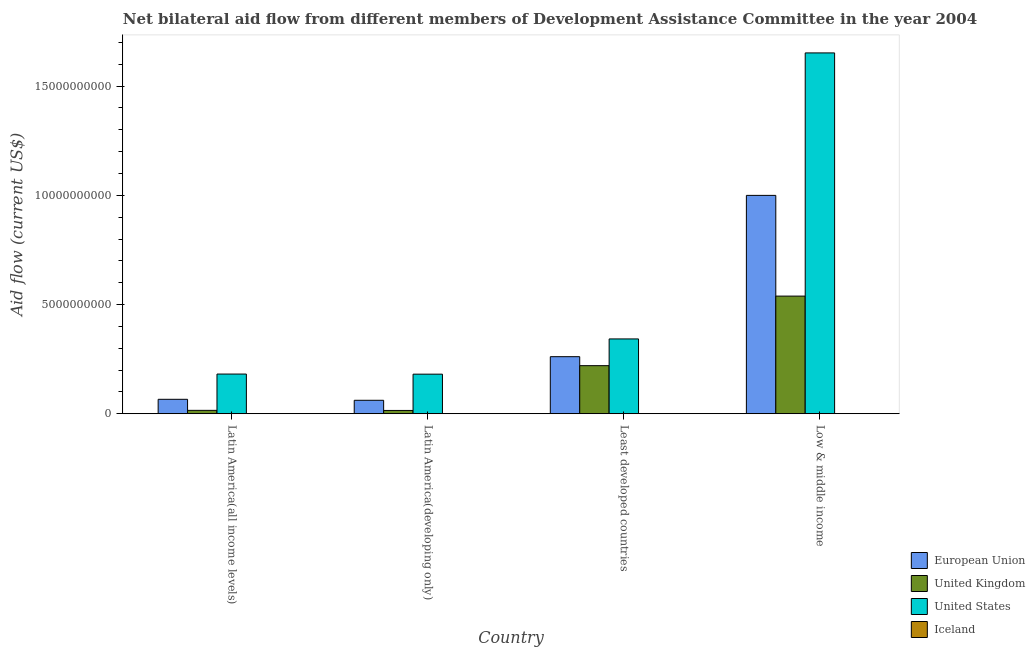How many different coloured bars are there?
Provide a succinct answer. 4. How many groups of bars are there?
Offer a very short reply. 4. Are the number of bars per tick equal to the number of legend labels?
Provide a succinct answer. Yes. How many bars are there on the 1st tick from the right?
Offer a terse response. 4. What is the label of the 1st group of bars from the left?
Your answer should be very brief. Latin America(all income levels). In how many cases, is the number of bars for a given country not equal to the number of legend labels?
Your response must be concise. 0. What is the amount of aid given by uk in Least developed countries?
Keep it short and to the point. 2.20e+09. Across all countries, what is the maximum amount of aid given by eu?
Your answer should be compact. 1.00e+1. Across all countries, what is the minimum amount of aid given by us?
Provide a succinct answer. 1.81e+09. In which country was the amount of aid given by uk minimum?
Your response must be concise. Latin America(developing only). What is the total amount of aid given by uk in the graph?
Your answer should be very brief. 7.89e+09. What is the difference between the amount of aid given by eu in Latin America(all income levels) and that in Latin America(developing only)?
Your response must be concise. 4.48e+07. What is the difference between the amount of aid given by eu in Latin America(developing only) and the amount of aid given by iceland in Low & middle income?
Provide a succinct answer. 6.16e+08. What is the average amount of aid given by eu per country?
Your response must be concise. 3.47e+09. What is the difference between the amount of aid given by uk and amount of aid given by us in Low & middle income?
Provide a short and direct response. -1.11e+1. In how many countries, is the amount of aid given by iceland greater than 13000000000 US$?
Ensure brevity in your answer.  0. What is the ratio of the amount of aid given by eu in Least developed countries to that in Low & middle income?
Provide a short and direct response. 0.26. Is the amount of aid given by uk in Latin America(all income levels) less than that in Latin America(developing only)?
Offer a very short reply. No. Is the difference between the amount of aid given by uk in Latin America(all income levels) and Low & middle income greater than the difference between the amount of aid given by eu in Latin America(all income levels) and Low & middle income?
Offer a terse response. Yes. What is the difference between the highest and the second highest amount of aid given by uk?
Provide a short and direct response. 3.18e+09. What is the difference between the highest and the lowest amount of aid given by iceland?
Offer a terse response. 7.55e+06. Is it the case that in every country, the sum of the amount of aid given by us and amount of aid given by eu is greater than the sum of amount of aid given by iceland and amount of aid given by uk?
Provide a short and direct response. No. Are all the bars in the graph horizontal?
Give a very brief answer. No. Does the graph contain any zero values?
Offer a very short reply. No. Does the graph contain grids?
Provide a short and direct response. No. Where does the legend appear in the graph?
Provide a short and direct response. Bottom right. How many legend labels are there?
Keep it short and to the point. 4. How are the legend labels stacked?
Make the answer very short. Vertical. What is the title of the graph?
Provide a short and direct response. Net bilateral aid flow from different members of Development Assistance Committee in the year 2004. Does "Other Minerals" appear as one of the legend labels in the graph?
Keep it short and to the point. No. What is the Aid flow (current US$) in European Union in Latin America(all income levels)?
Give a very brief answer. 6.61e+08. What is the Aid flow (current US$) of United Kingdom in Latin America(all income levels)?
Provide a short and direct response. 1.55e+08. What is the Aid flow (current US$) of United States in Latin America(all income levels)?
Your answer should be compact. 1.82e+09. What is the Aid flow (current US$) of Iceland in Latin America(all income levels)?
Ensure brevity in your answer.  6.01e+06. What is the Aid flow (current US$) of European Union in Latin America(developing only)?
Make the answer very short. 6.16e+08. What is the Aid flow (current US$) in United Kingdom in Latin America(developing only)?
Your response must be concise. 1.51e+08. What is the Aid flow (current US$) of United States in Latin America(developing only)?
Your answer should be very brief. 1.81e+09. What is the Aid flow (current US$) of Iceland in Latin America(developing only)?
Your response must be concise. 2.86e+06. What is the Aid flow (current US$) of European Union in Least developed countries?
Make the answer very short. 2.61e+09. What is the Aid flow (current US$) in United Kingdom in Least developed countries?
Provide a short and direct response. 2.20e+09. What is the Aid flow (current US$) of United States in Least developed countries?
Offer a very short reply. 3.43e+09. What is the Aid flow (current US$) in Iceland in Least developed countries?
Provide a succinct answer. 7.60e+06. What is the Aid flow (current US$) of European Union in Low & middle income?
Your answer should be very brief. 1.00e+1. What is the Aid flow (current US$) of United Kingdom in Low & middle income?
Keep it short and to the point. 5.39e+09. What is the Aid flow (current US$) of United States in Low & middle income?
Offer a very short reply. 1.65e+1. What is the Aid flow (current US$) in Iceland in Low & middle income?
Your response must be concise. 5.00e+04. Across all countries, what is the maximum Aid flow (current US$) of European Union?
Your answer should be very brief. 1.00e+1. Across all countries, what is the maximum Aid flow (current US$) in United Kingdom?
Ensure brevity in your answer.  5.39e+09. Across all countries, what is the maximum Aid flow (current US$) in United States?
Keep it short and to the point. 1.65e+1. Across all countries, what is the maximum Aid flow (current US$) of Iceland?
Your response must be concise. 7.60e+06. Across all countries, what is the minimum Aid flow (current US$) of European Union?
Keep it short and to the point. 6.16e+08. Across all countries, what is the minimum Aid flow (current US$) in United Kingdom?
Offer a very short reply. 1.51e+08. Across all countries, what is the minimum Aid flow (current US$) in United States?
Ensure brevity in your answer.  1.81e+09. Across all countries, what is the minimum Aid flow (current US$) in Iceland?
Ensure brevity in your answer.  5.00e+04. What is the total Aid flow (current US$) in European Union in the graph?
Offer a very short reply. 1.39e+1. What is the total Aid flow (current US$) in United Kingdom in the graph?
Offer a terse response. 7.89e+09. What is the total Aid flow (current US$) in United States in the graph?
Keep it short and to the point. 2.36e+1. What is the total Aid flow (current US$) in Iceland in the graph?
Offer a terse response. 1.65e+07. What is the difference between the Aid flow (current US$) of European Union in Latin America(all income levels) and that in Latin America(developing only)?
Your answer should be compact. 4.48e+07. What is the difference between the Aid flow (current US$) of United Kingdom in Latin America(all income levels) and that in Latin America(developing only)?
Offer a terse response. 4.27e+06. What is the difference between the Aid flow (current US$) in United States in Latin America(all income levels) and that in Latin America(developing only)?
Your answer should be very brief. 4.96e+06. What is the difference between the Aid flow (current US$) in Iceland in Latin America(all income levels) and that in Latin America(developing only)?
Offer a very short reply. 3.15e+06. What is the difference between the Aid flow (current US$) in European Union in Latin America(all income levels) and that in Least developed countries?
Make the answer very short. -1.95e+09. What is the difference between the Aid flow (current US$) in United Kingdom in Latin America(all income levels) and that in Least developed countries?
Your response must be concise. -2.05e+09. What is the difference between the Aid flow (current US$) in United States in Latin America(all income levels) and that in Least developed countries?
Make the answer very short. -1.61e+09. What is the difference between the Aid flow (current US$) of Iceland in Latin America(all income levels) and that in Least developed countries?
Ensure brevity in your answer.  -1.59e+06. What is the difference between the Aid flow (current US$) in European Union in Latin America(all income levels) and that in Low & middle income?
Offer a terse response. -9.34e+09. What is the difference between the Aid flow (current US$) of United Kingdom in Latin America(all income levels) and that in Low & middle income?
Your answer should be very brief. -5.23e+09. What is the difference between the Aid flow (current US$) in United States in Latin America(all income levels) and that in Low & middle income?
Your response must be concise. -1.47e+1. What is the difference between the Aid flow (current US$) of Iceland in Latin America(all income levels) and that in Low & middle income?
Make the answer very short. 5.96e+06. What is the difference between the Aid flow (current US$) of European Union in Latin America(developing only) and that in Least developed countries?
Provide a short and direct response. -2.00e+09. What is the difference between the Aid flow (current US$) of United Kingdom in Latin America(developing only) and that in Least developed countries?
Keep it short and to the point. -2.05e+09. What is the difference between the Aid flow (current US$) in United States in Latin America(developing only) and that in Least developed countries?
Give a very brief answer. -1.61e+09. What is the difference between the Aid flow (current US$) in Iceland in Latin America(developing only) and that in Least developed countries?
Your answer should be very brief. -4.74e+06. What is the difference between the Aid flow (current US$) in European Union in Latin America(developing only) and that in Low & middle income?
Offer a very short reply. -9.38e+09. What is the difference between the Aid flow (current US$) in United Kingdom in Latin America(developing only) and that in Low & middle income?
Provide a short and direct response. -5.24e+09. What is the difference between the Aid flow (current US$) of United States in Latin America(developing only) and that in Low & middle income?
Offer a terse response. -1.47e+1. What is the difference between the Aid flow (current US$) in Iceland in Latin America(developing only) and that in Low & middle income?
Your answer should be very brief. 2.81e+06. What is the difference between the Aid flow (current US$) in European Union in Least developed countries and that in Low & middle income?
Provide a short and direct response. -7.39e+09. What is the difference between the Aid flow (current US$) in United Kingdom in Least developed countries and that in Low & middle income?
Your answer should be very brief. -3.18e+09. What is the difference between the Aid flow (current US$) in United States in Least developed countries and that in Low & middle income?
Give a very brief answer. -1.31e+1. What is the difference between the Aid flow (current US$) in Iceland in Least developed countries and that in Low & middle income?
Keep it short and to the point. 7.55e+06. What is the difference between the Aid flow (current US$) in European Union in Latin America(all income levels) and the Aid flow (current US$) in United Kingdom in Latin America(developing only)?
Make the answer very short. 5.10e+08. What is the difference between the Aid flow (current US$) of European Union in Latin America(all income levels) and the Aid flow (current US$) of United States in Latin America(developing only)?
Offer a terse response. -1.15e+09. What is the difference between the Aid flow (current US$) of European Union in Latin America(all income levels) and the Aid flow (current US$) of Iceland in Latin America(developing only)?
Keep it short and to the point. 6.58e+08. What is the difference between the Aid flow (current US$) in United Kingdom in Latin America(all income levels) and the Aid flow (current US$) in United States in Latin America(developing only)?
Offer a very short reply. -1.66e+09. What is the difference between the Aid flow (current US$) of United Kingdom in Latin America(all income levels) and the Aid flow (current US$) of Iceland in Latin America(developing only)?
Give a very brief answer. 1.52e+08. What is the difference between the Aid flow (current US$) of United States in Latin America(all income levels) and the Aid flow (current US$) of Iceland in Latin America(developing only)?
Offer a terse response. 1.81e+09. What is the difference between the Aid flow (current US$) of European Union in Latin America(all income levels) and the Aid flow (current US$) of United Kingdom in Least developed countries?
Make the answer very short. -1.54e+09. What is the difference between the Aid flow (current US$) in European Union in Latin America(all income levels) and the Aid flow (current US$) in United States in Least developed countries?
Provide a succinct answer. -2.76e+09. What is the difference between the Aid flow (current US$) in European Union in Latin America(all income levels) and the Aid flow (current US$) in Iceland in Least developed countries?
Provide a short and direct response. 6.53e+08. What is the difference between the Aid flow (current US$) of United Kingdom in Latin America(all income levels) and the Aid flow (current US$) of United States in Least developed countries?
Keep it short and to the point. -3.27e+09. What is the difference between the Aid flow (current US$) in United Kingdom in Latin America(all income levels) and the Aid flow (current US$) in Iceland in Least developed countries?
Make the answer very short. 1.48e+08. What is the difference between the Aid flow (current US$) of United States in Latin America(all income levels) and the Aid flow (current US$) of Iceland in Least developed countries?
Provide a succinct answer. 1.81e+09. What is the difference between the Aid flow (current US$) in European Union in Latin America(all income levels) and the Aid flow (current US$) in United Kingdom in Low & middle income?
Give a very brief answer. -4.73e+09. What is the difference between the Aid flow (current US$) in European Union in Latin America(all income levels) and the Aid flow (current US$) in United States in Low & middle income?
Your answer should be compact. -1.59e+1. What is the difference between the Aid flow (current US$) in European Union in Latin America(all income levels) and the Aid flow (current US$) in Iceland in Low & middle income?
Provide a succinct answer. 6.61e+08. What is the difference between the Aid flow (current US$) in United Kingdom in Latin America(all income levels) and the Aid flow (current US$) in United States in Low & middle income?
Keep it short and to the point. -1.64e+1. What is the difference between the Aid flow (current US$) of United Kingdom in Latin America(all income levels) and the Aid flow (current US$) of Iceland in Low & middle income?
Give a very brief answer. 1.55e+08. What is the difference between the Aid flow (current US$) in United States in Latin America(all income levels) and the Aid flow (current US$) in Iceland in Low & middle income?
Ensure brevity in your answer.  1.82e+09. What is the difference between the Aid flow (current US$) of European Union in Latin America(developing only) and the Aid flow (current US$) of United Kingdom in Least developed countries?
Make the answer very short. -1.59e+09. What is the difference between the Aid flow (current US$) of European Union in Latin America(developing only) and the Aid flow (current US$) of United States in Least developed countries?
Keep it short and to the point. -2.81e+09. What is the difference between the Aid flow (current US$) of European Union in Latin America(developing only) and the Aid flow (current US$) of Iceland in Least developed countries?
Your response must be concise. 6.08e+08. What is the difference between the Aid flow (current US$) of United Kingdom in Latin America(developing only) and the Aid flow (current US$) of United States in Least developed countries?
Ensure brevity in your answer.  -3.27e+09. What is the difference between the Aid flow (current US$) of United Kingdom in Latin America(developing only) and the Aid flow (current US$) of Iceland in Least developed countries?
Your response must be concise. 1.43e+08. What is the difference between the Aid flow (current US$) in United States in Latin America(developing only) and the Aid flow (current US$) in Iceland in Least developed countries?
Offer a very short reply. 1.80e+09. What is the difference between the Aid flow (current US$) of European Union in Latin America(developing only) and the Aid flow (current US$) of United Kingdom in Low & middle income?
Provide a succinct answer. -4.77e+09. What is the difference between the Aid flow (current US$) of European Union in Latin America(developing only) and the Aid flow (current US$) of United States in Low & middle income?
Your response must be concise. -1.59e+1. What is the difference between the Aid flow (current US$) in European Union in Latin America(developing only) and the Aid flow (current US$) in Iceland in Low & middle income?
Your response must be concise. 6.16e+08. What is the difference between the Aid flow (current US$) in United Kingdom in Latin America(developing only) and the Aid flow (current US$) in United States in Low & middle income?
Offer a terse response. -1.64e+1. What is the difference between the Aid flow (current US$) in United Kingdom in Latin America(developing only) and the Aid flow (current US$) in Iceland in Low & middle income?
Your answer should be compact. 1.51e+08. What is the difference between the Aid flow (current US$) in United States in Latin America(developing only) and the Aid flow (current US$) in Iceland in Low & middle income?
Offer a terse response. 1.81e+09. What is the difference between the Aid flow (current US$) in European Union in Least developed countries and the Aid flow (current US$) in United Kingdom in Low & middle income?
Make the answer very short. -2.77e+09. What is the difference between the Aid flow (current US$) of European Union in Least developed countries and the Aid flow (current US$) of United States in Low & middle income?
Make the answer very short. -1.39e+1. What is the difference between the Aid flow (current US$) of European Union in Least developed countries and the Aid flow (current US$) of Iceland in Low & middle income?
Keep it short and to the point. 2.61e+09. What is the difference between the Aid flow (current US$) of United Kingdom in Least developed countries and the Aid flow (current US$) of United States in Low & middle income?
Offer a very short reply. -1.43e+1. What is the difference between the Aid flow (current US$) in United Kingdom in Least developed countries and the Aid flow (current US$) in Iceland in Low & middle income?
Provide a short and direct response. 2.20e+09. What is the difference between the Aid flow (current US$) in United States in Least developed countries and the Aid flow (current US$) in Iceland in Low & middle income?
Make the answer very short. 3.43e+09. What is the average Aid flow (current US$) in European Union per country?
Your answer should be compact. 3.47e+09. What is the average Aid flow (current US$) in United Kingdom per country?
Make the answer very short. 1.97e+09. What is the average Aid flow (current US$) of United States per country?
Give a very brief answer. 5.89e+09. What is the average Aid flow (current US$) in Iceland per country?
Your response must be concise. 4.13e+06. What is the difference between the Aid flow (current US$) in European Union and Aid flow (current US$) in United Kingdom in Latin America(all income levels)?
Keep it short and to the point. 5.05e+08. What is the difference between the Aid flow (current US$) in European Union and Aid flow (current US$) in United States in Latin America(all income levels)?
Ensure brevity in your answer.  -1.16e+09. What is the difference between the Aid flow (current US$) in European Union and Aid flow (current US$) in Iceland in Latin America(all income levels)?
Give a very brief answer. 6.55e+08. What is the difference between the Aid flow (current US$) of United Kingdom and Aid flow (current US$) of United States in Latin America(all income levels)?
Provide a succinct answer. -1.66e+09. What is the difference between the Aid flow (current US$) in United Kingdom and Aid flow (current US$) in Iceland in Latin America(all income levels)?
Ensure brevity in your answer.  1.49e+08. What is the difference between the Aid flow (current US$) in United States and Aid flow (current US$) in Iceland in Latin America(all income levels)?
Make the answer very short. 1.81e+09. What is the difference between the Aid flow (current US$) in European Union and Aid flow (current US$) in United Kingdom in Latin America(developing only)?
Offer a very short reply. 4.65e+08. What is the difference between the Aid flow (current US$) of European Union and Aid flow (current US$) of United States in Latin America(developing only)?
Make the answer very short. -1.20e+09. What is the difference between the Aid flow (current US$) in European Union and Aid flow (current US$) in Iceland in Latin America(developing only)?
Your answer should be very brief. 6.13e+08. What is the difference between the Aid flow (current US$) in United Kingdom and Aid flow (current US$) in United States in Latin America(developing only)?
Your answer should be very brief. -1.66e+09. What is the difference between the Aid flow (current US$) in United Kingdom and Aid flow (current US$) in Iceland in Latin America(developing only)?
Ensure brevity in your answer.  1.48e+08. What is the difference between the Aid flow (current US$) in United States and Aid flow (current US$) in Iceland in Latin America(developing only)?
Your answer should be compact. 1.81e+09. What is the difference between the Aid flow (current US$) of European Union and Aid flow (current US$) of United Kingdom in Least developed countries?
Make the answer very short. 4.11e+08. What is the difference between the Aid flow (current US$) of European Union and Aid flow (current US$) of United States in Least developed countries?
Your answer should be very brief. -8.13e+08. What is the difference between the Aid flow (current US$) of European Union and Aid flow (current US$) of Iceland in Least developed countries?
Make the answer very short. 2.61e+09. What is the difference between the Aid flow (current US$) in United Kingdom and Aid flow (current US$) in United States in Least developed countries?
Provide a succinct answer. -1.22e+09. What is the difference between the Aid flow (current US$) in United Kingdom and Aid flow (current US$) in Iceland in Least developed countries?
Give a very brief answer. 2.19e+09. What is the difference between the Aid flow (current US$) of United States and Aid flow (current US$) of Iceland in Least developed countries?
Provide a short and direct response. 3.42e+09. What is the difference between the Aid flow (current US$) of European Union and Aid flow (current US$) of United Kingdom in Low & middle income?
Offer a very short reply. 4.61e+09. What is the difference between the Aid flow (current US$) of European Union and Aid flow (current US$) of United States in Low & middle income?
Your answer should be compact. -6.52e+09. What is the difference between the Aid flow (current US$) of European Union and Aid flow (current US$) of Iceland in Low & middle income?
Make the answer very short. 1.00e+1. What is the difference between the Aid flow (current US$) of United Kingdom and Aid flow (current US$) of United States in Low & middle income?
Offer a terse response. -1.11e+1. What is the difference between the Aid flow (current US$) in United Kingdom and Aid flow (current US$) in Iceland in Low & middle income?
Your answer should be compact. 5.39e+09. What is the difference between the Aid flow (current US$) of United States and Aid flow (current US$) of Iceland in Low & middle income?
Provide a short and direct response. 1.65e+1. What is the ratio of the Aid flow (current US$) in European Union in Latin America(all income levels) to that in Latin America(developing only)?
Give a very brief answer. 1.07. What is the ratio of the Aid flow (current US$) of United Kingdom in Latin America(all income levels) to that in Latin America(developing only)?
Your answer should be compact. 1.03. What is the ratio of the Aid flow (current US$) in Iceland in Latin America(all income levels) to that in Latin America(developing only)?
Make the answer very short. 2.1. What is the ratio of the Aid flow (current US$) of European Union in Latin America(all income levels) to that in Least developed countries?
Give a very brief answer. 0.25. What is the ratio of the Aid flow (current US$) of United Kingdom in Latin America(all income levels) to that in Least developed countries?
Give a very brief answer. 0.07. What is the ratio of the Aid flow (current US$) of United States in Latin America(all income levels) to that in Least developed countries?
Your answer should be compact. 0.53. What is the ratio of the Aid flow (current US$) in Iceland in Latin America(all income levels) to that in Least developed countries?
Keep it short and to the point. 0.79. What is the ratio of the Aid flow (current US$) in European Union in Latin America(all income levels) to that in Low & middle income?
Offer a very short reply. 0.07. What is the ratio of the Aid flow (current US$) in United Kingdom in Latin America(all income levels) to that in Low & middle income?
Your answer should be compact. 0.03. What is the ratio of the Aid flow (current US$) in United States in Latin America(all income levels) to that in Low & middle income?
Make the answer very short. 0.11. What is the ratio of the Aid flow (current US$) in Iceland in Latin America(all income levels) to that in Low & middle income?
Make the answer very short. 120.2. What is the ratio of the Aid flow (current US$) in European Union in Latin America(developing only) to that in Least developed countries?
Make the answer very short. 0.24. What is the ratio of the Aid flow (current US$) in United Kingdom in Latin America(developing only) to that in Least developed countries?
Your answer should be compact. 0.07. What is the ratio of the Aid flow (current US$) of United States in Latin America(developing only) to that in Least developed countries?
Ensure brevity in your answer.  0.53. What is the ratio of the Aid flow (current US$) in Iceland in Latin America(developing only) to that in Least developed countries?
Make the answer very short. 0.38. What is the ratio of the Aid flow (current US$) in European Union in Latin America(developing only) to that in Low & middle income?
Offer a very short reply. 0.06. What is the ratio of the Aid flow (current US$) in United Kingdom in Latin America(developing only) to that in Low & middle income?
Make the answer very short. 0.03. What is the ratio of the Aid flow (current US$) of United States in Latin America(developing only) to that in Low & middle income?
Give a very brief answer. 0.11. What is the ratio of the Aid flow (current US$) of Iceland in Latin America(developing only) to that in Low & middle income?
Give a very brief answer. 57.2. What is the ratio of the Aid flow (current US$) in European Union in Least developed countries to that in Low & middle income?
Ensure brevity in your answer.  0.26. What is the ratio of the Aid flow (current US$) in United Kingdom in Least developed countries to that in Low & middle income?
Keep it short and to the point. 0.41. What is the ratio of the Aid flow (current US$) of United States in Least developed countries to that in Low & middle income?
Provide a short and direct response. 0.21. What is the ratio of the Aid flow (current US$) of Iceland in Least developed countries to that in Low & middle income?
Offer a very short reply. 152. What is the difference between the highest and the second highest Aid flow (current US$) of European Union?
Provide a succinct answer. 7.39e+09. What is the difference between the highest and the second highest Aid flow (current US$) in United Kingdom?
Your response must be concise. 3.18e+09. What is the difference between the highest and the second highest Aid flow (current US$) of United States?
Make the answer very short. 1.31e+1. What is the difference between the highest and the second highest Aid flow (current US$) of Iceland?
Offer a terse response. 1.59e+06. What is the difference between the highest and the lowest Aid flow (current US$) of European Union?
Your answer should be compact. 9.38e+09. What is the difference between the highest and the lowest Aid flow (current US$) in United Kingdom?
Provide a short and direct response. 5.24e+09. What is the difference between the highest and the lowest Aid flow (current US$) in United States?
Ensure brevity in your answer.  1.47e+1. What is the difference between the highest and the lowest Aid flow (current US$) of Iceland?
Ensure brevity in your answer.  7.55e+06. 